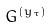<formula> <loc_0><loc_0><loc_500><loc_500>G ^ { ( y _ { \tau } ) }</formula> 